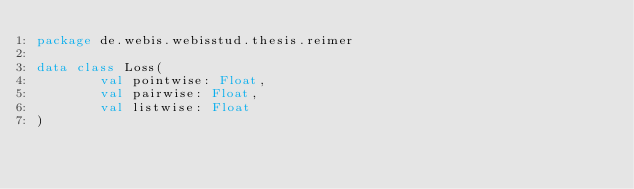<code> <loc_0><loc_0><loc_500><loc_500><_Kotlin_>package de.webis.webisstud.thesis.reimer

data class Loss(
        val pointwise: Float,
        val pairwise: Float,
        val listwise: Float
)</code> 